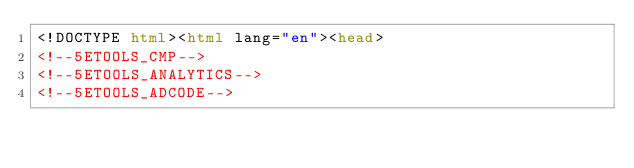<code> <loc_0><loc_0><loc_500><loc_500><_HTML_><!DOCTYPE html><html lang="en"><head>
<!--5ETOOLS_CMP-->
<!--5ETOOLS_ANALYTICS-->
<!--5ETOOLS_ADCODE--></code> 